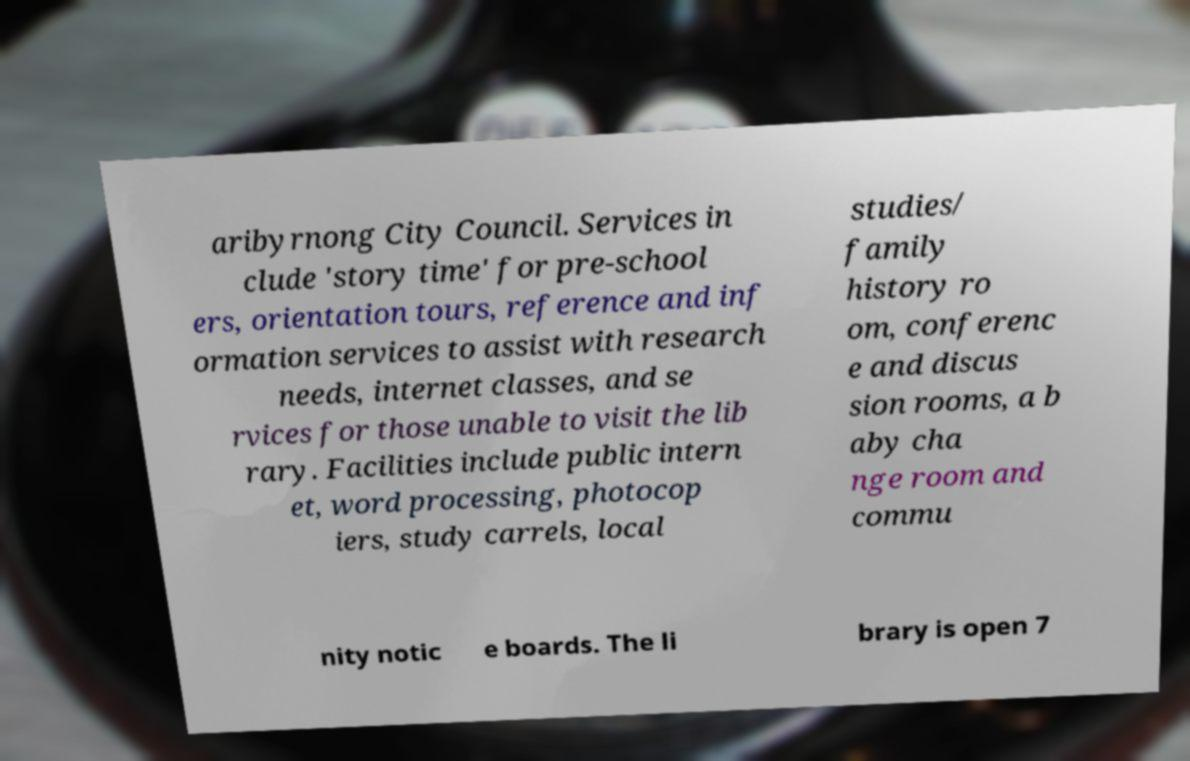For documentation purposes, I need the text within this image transcribed. Could you provide that? aribyrnong City Council. Services in clude 'story time' for pre-school ers, orientation tours, reference and inf ormation services to assist with research needs, internet classes, and se rvices for those unable to visit the lib rary. Facilities include public intern et, word processing, photocop iers, study carrels, local studies/ family history ro om, conferenc e and discus sion rooms, a b aby cha nge room and commu nity notic e boards. The li brary is open 7 